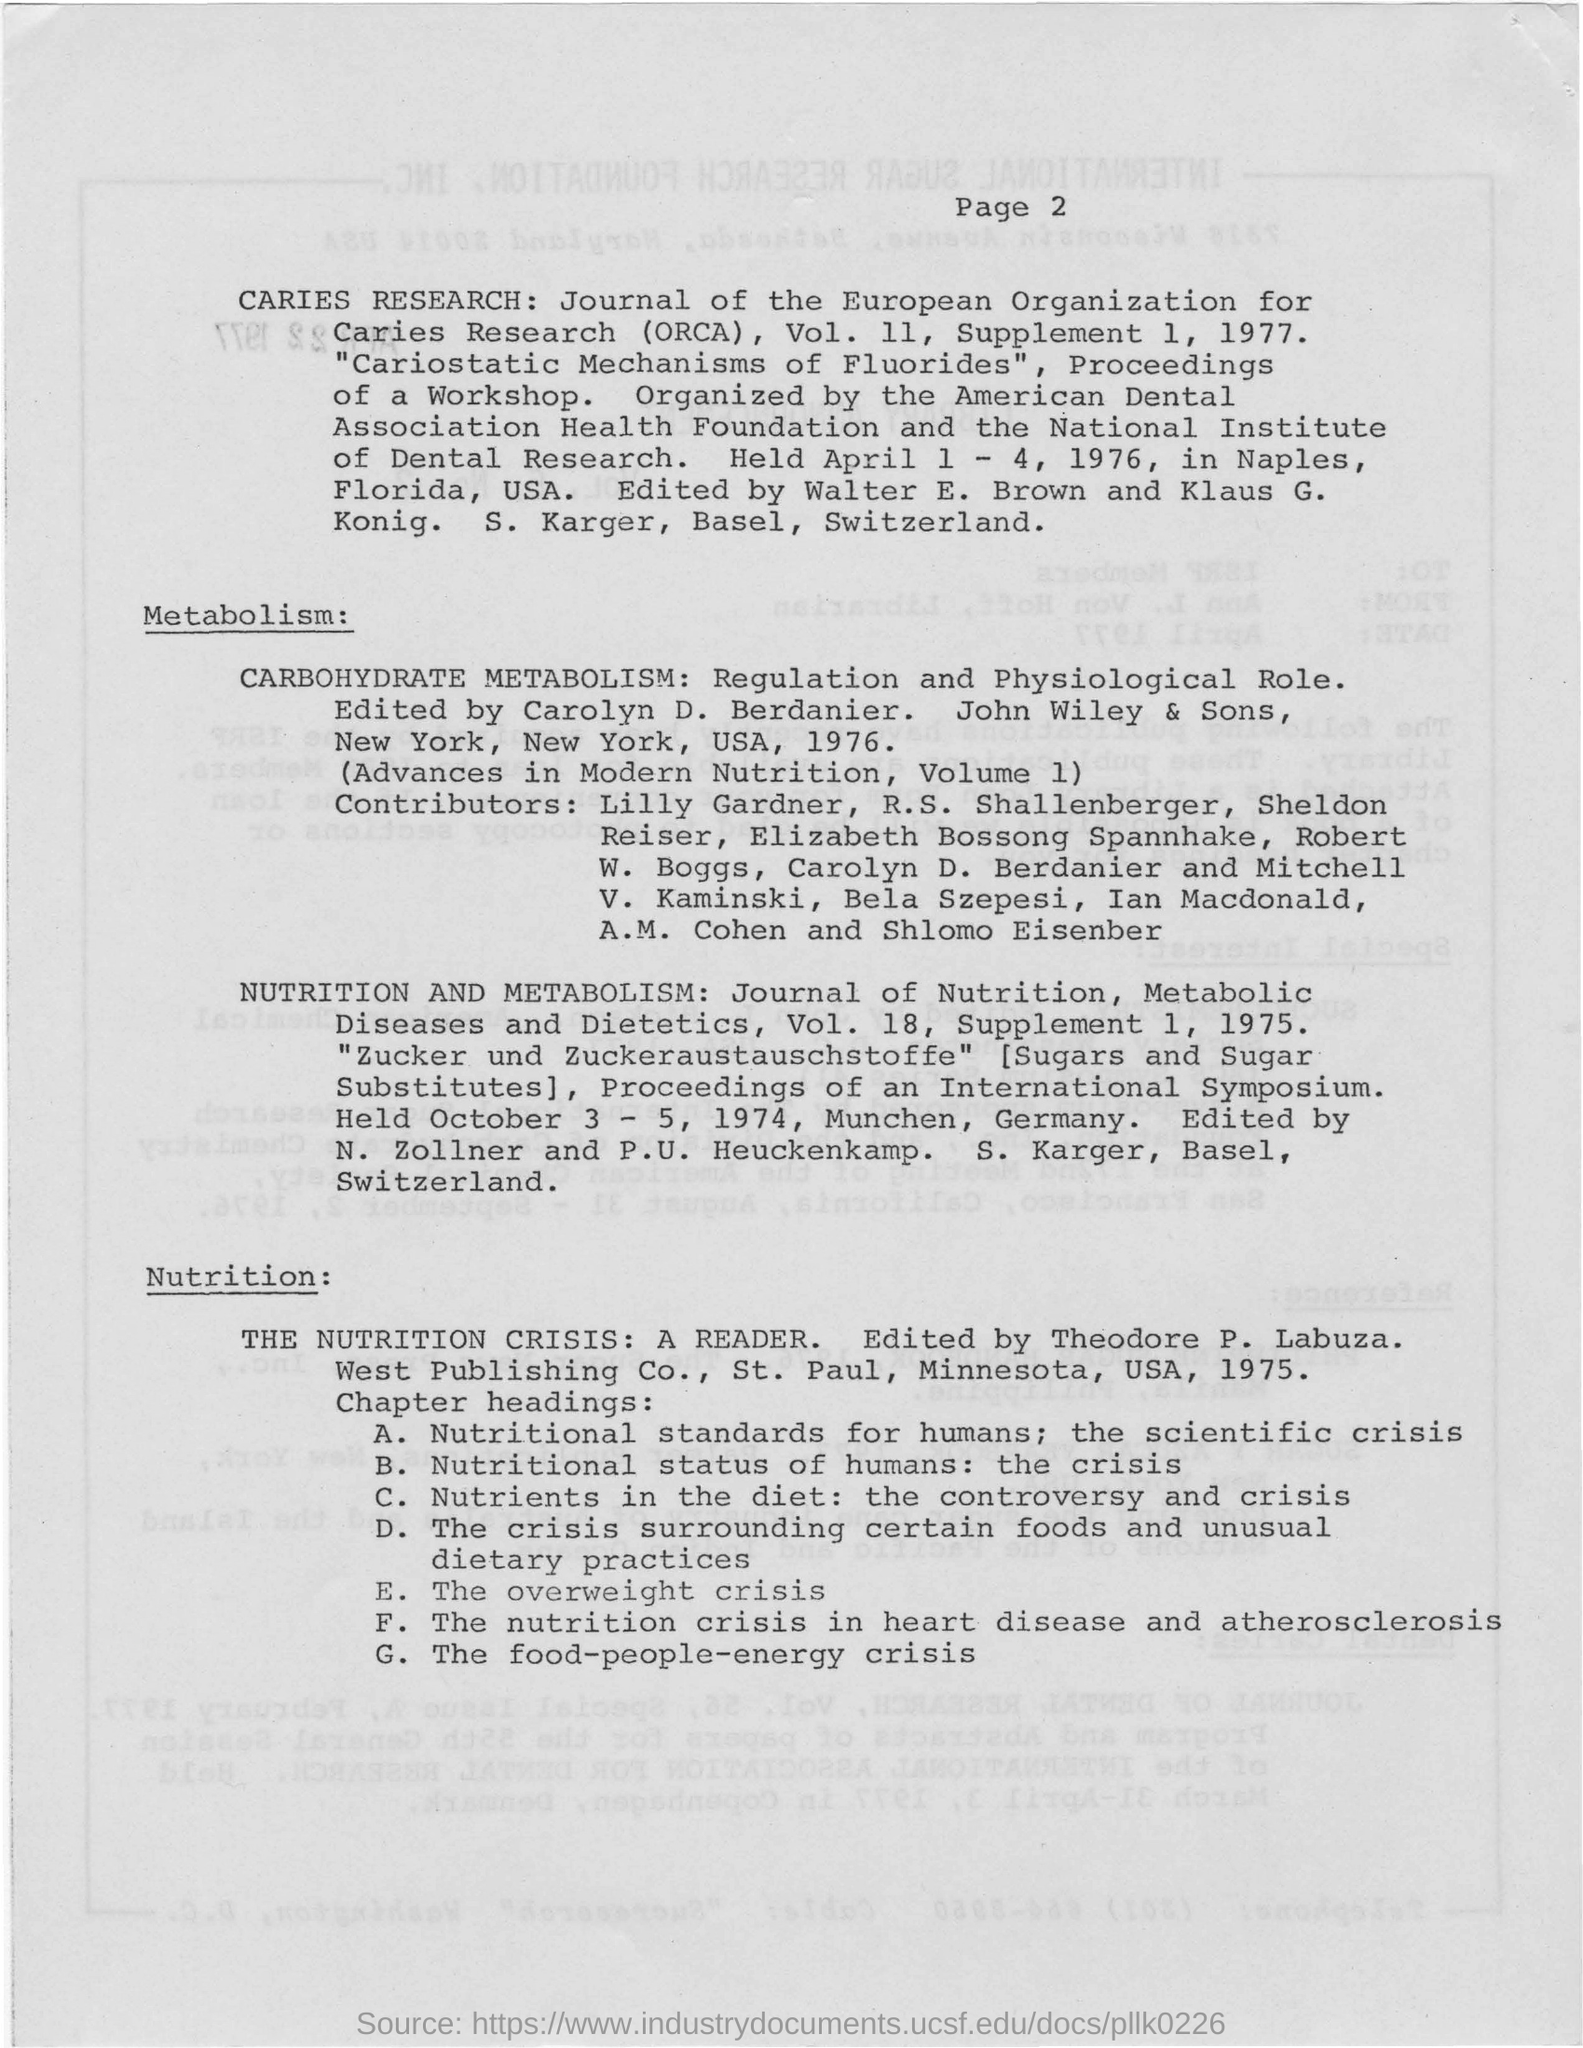What is the fullform of ORCA?
Provide a short and direct response. Organization for Caries Research. 